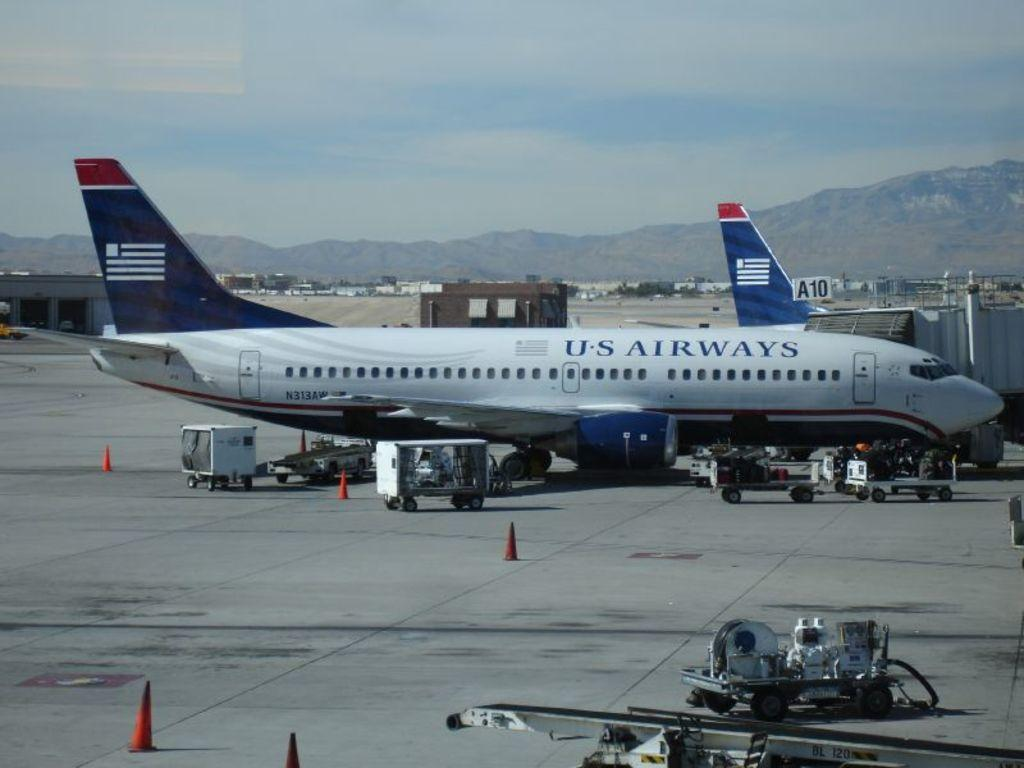<image>
Summarize the visual content of the image. An US Airways airplane parked on the tarmac up against a terminal 